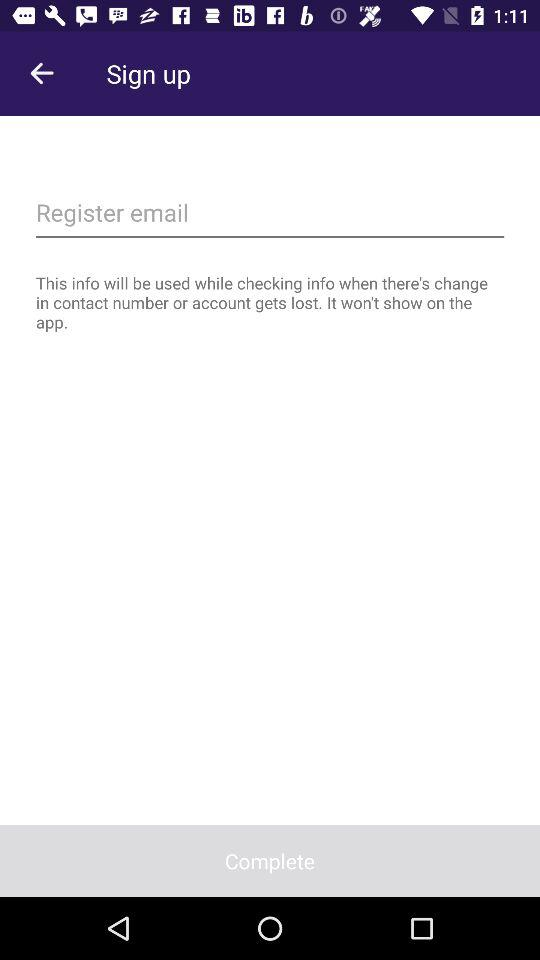How do I set up email?
When the provided information is insufficient, respond with <no answer>. <no answer> 